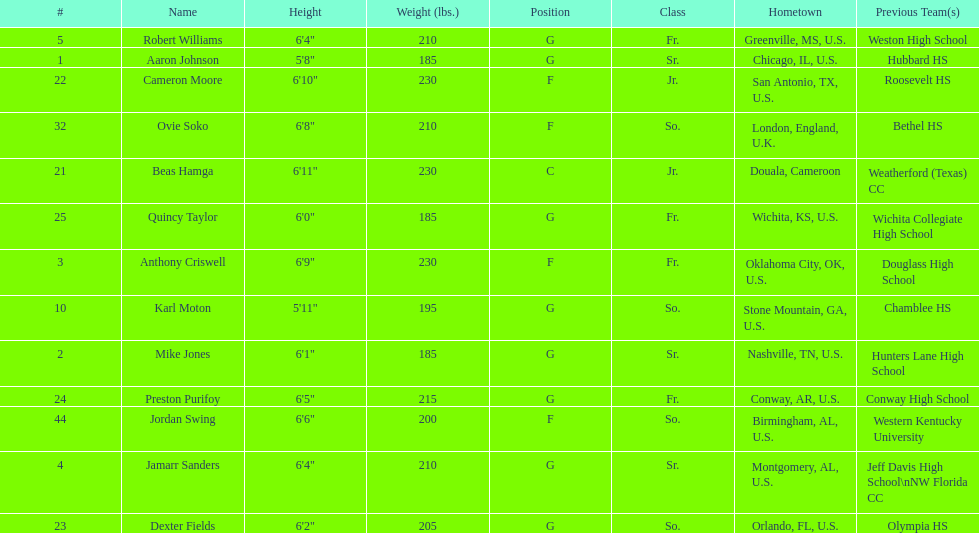How many forwards are there in total on the team? 4. 